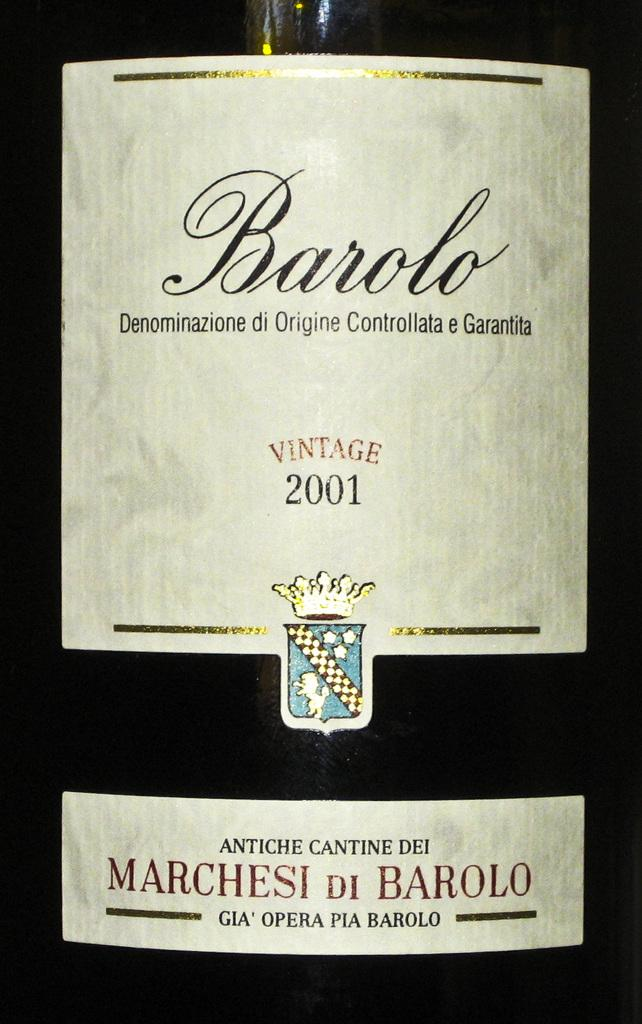<image>
Create a compact narrative representing the image presented. A wine label saying Barolo brand vintage wine from 2001 is shown. 